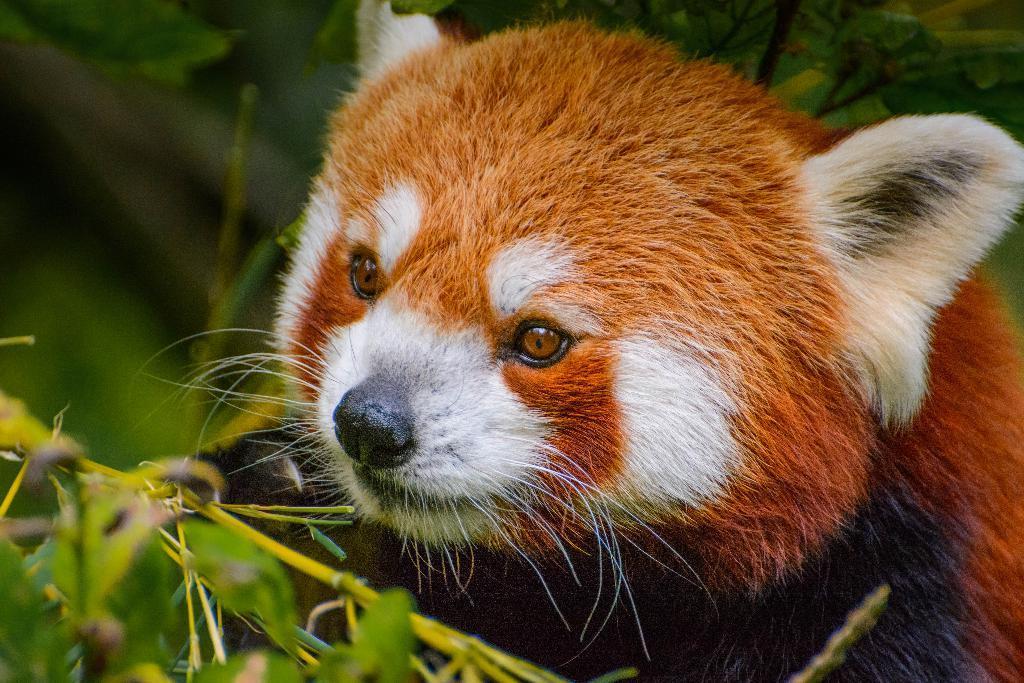Can you describe this image briefly? In the picture we can see an animal which is brown and some white in color near the plants. 